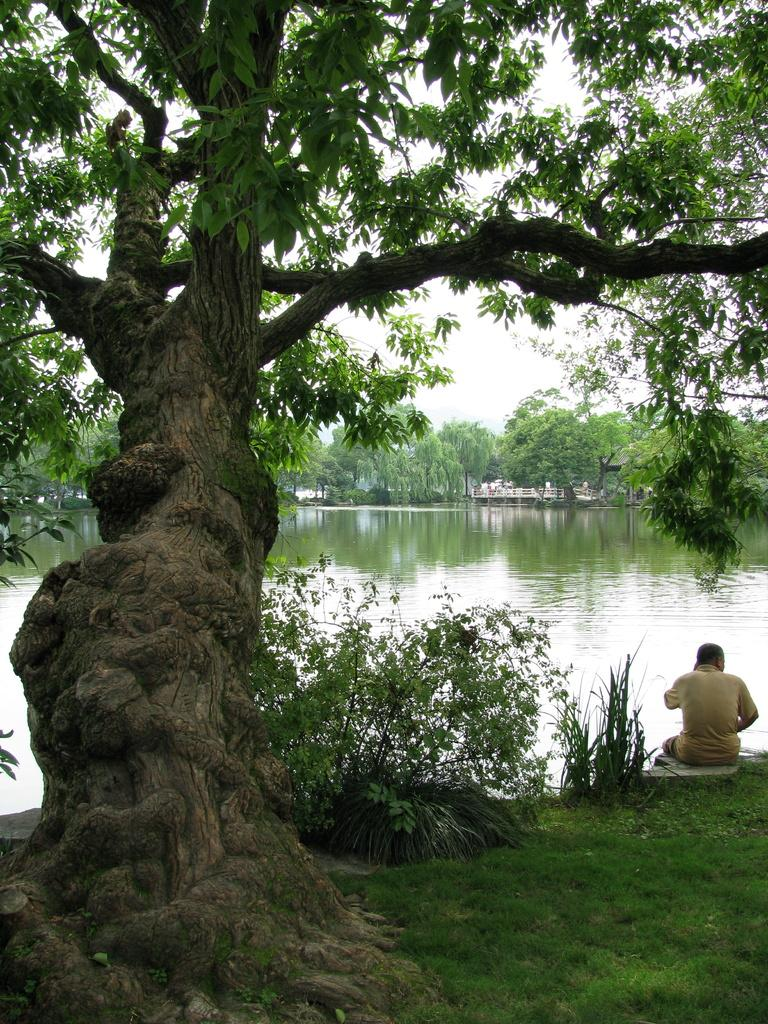What type of vegetation can be seen in the image? There are trees and plants visible in the image. What natural element is present in the image? Water is visible in the image. What type of ground cover is present in the image? There is grass in the image. What is the person in the image doing? The person is sitting in the image. What type of match is the person playing in the image? There is no match or any sporting activity depicted in the image; it features a person sitting amidst vegetation and natural elements. What subject is the person teaching in the image? There is no indication of teaching or any educational activity in the image; it simply shows a person sitting in a natural setting. 